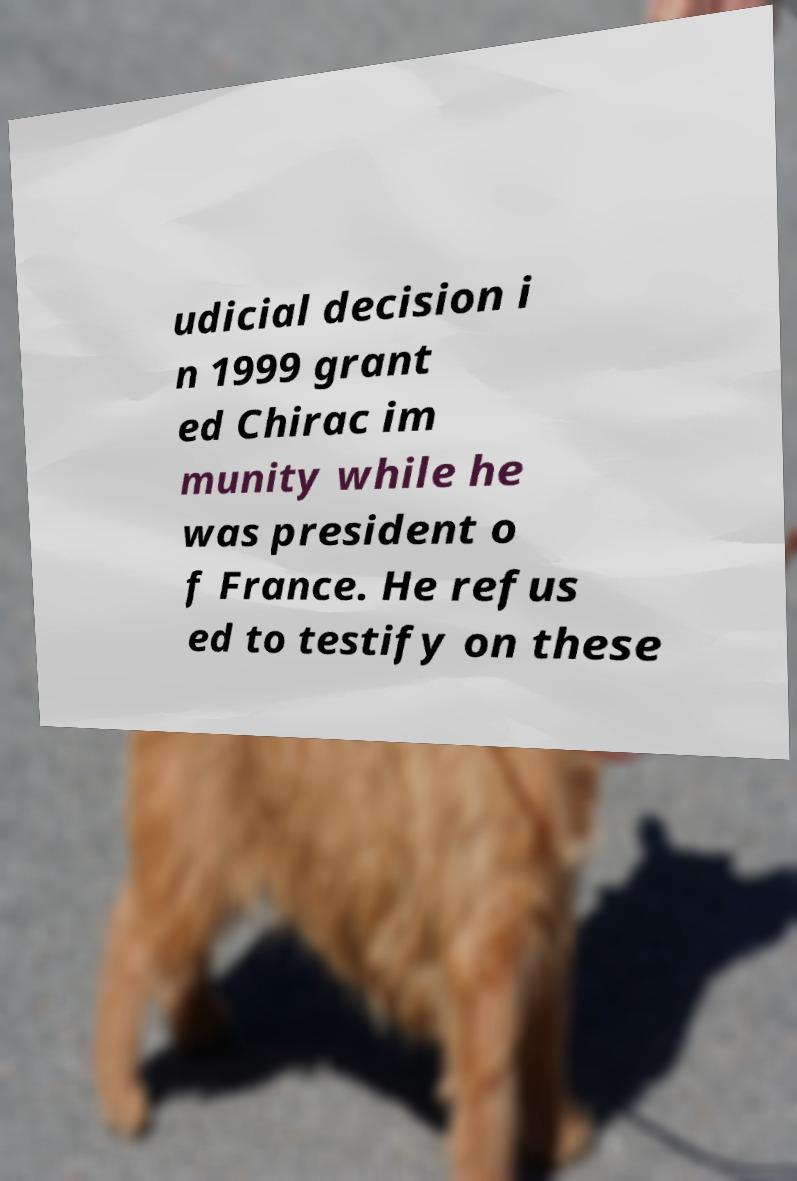Please read and relay the text visible in this image. What does it say? udicial decision i n 1999 grant ed Chirac im munity while he was president o f France. He refus ed to testify on these 